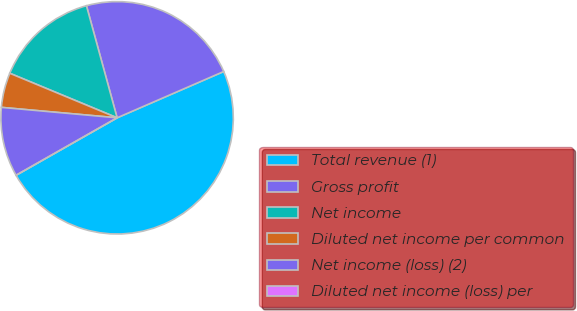Convert chart. <chart><loc_0><loc_0><loc_500><loc_500><pie_chart><fcel>Total revenue (1)<fcel>Gross profit<fcel>Net income<fcel>Diluted net income per common<fcel>Net income (loss) (2)<fcel>Diluted net income (loss) per<nl><fcel>48.3%<fcel>22.73%<fcel>14.49%<fcel>4.83%<fcel>9.66%<fcel>0.0%<nl></chart> 